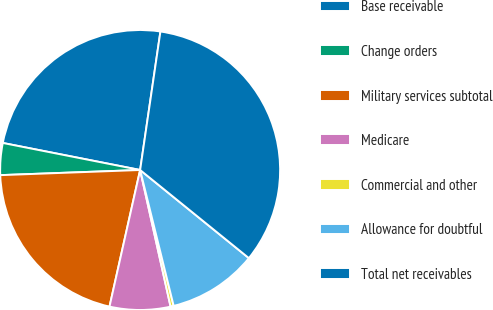Convert chart to OTSL. <chart><loc_0><loc_0><loc_500><loc_500><pie_chart><fcel>Base receivable<fcel>Change orders<fcel>Military services subtotal<fcel>Medicare<fcel>Commercial and other<fcel>Allowance for doubtful<fcel>Total net receivables<nl><fcel>24.22%<fcel>3.68%<fcel>20.9%<fcel>7.0%<fcel>0.36%<fcel>10.31%<fcel>33.52%<nl></chart> 